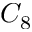<formula> <loc_0><loc_0><loc_500><loc_500>C _ { 8 }</formula> 